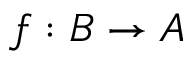<formula> <loc_0><loc_0><loc_500><loc_500>f \colon B \rightarrow A</formula> 